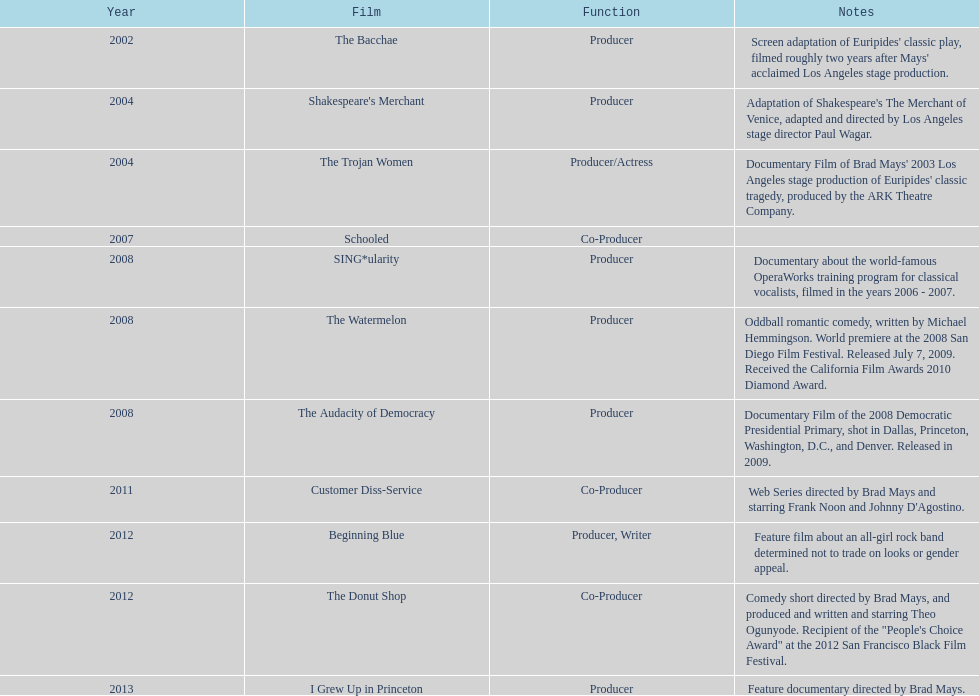Which motion picture was prior to the audacity of democracy? The Watermelon. 